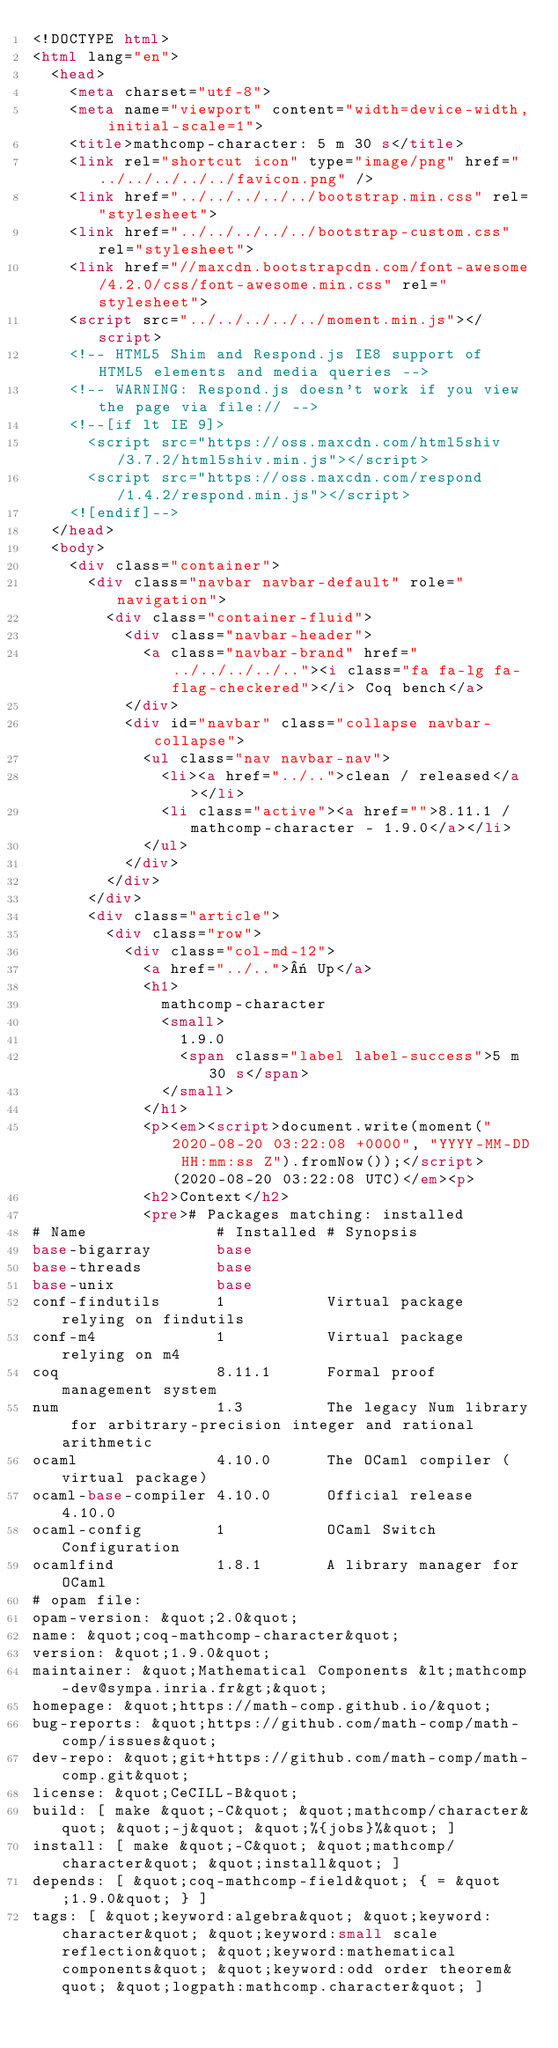<code> <loc_0><loc_0><loc_500><loc_500><_HTML_><!DOCTYPE html>
<html lang="en">
  <head>
    <meta charset="utf-8">
    <meta name="viewport" content="width=device-width, initial-scale=1">
    <title>mathcomp-character: 5 m 30 s</title>
    <link rel="shortcut icon" type="image/png" href="../../../../../favicon.png" />
    <link href="../../../../../bootstrap.min.css" rel="stylesheet">
    <link href="../../../../../bootstrap-custom.css" rel="stylesheet">
    <link href="//maxcdn.bootstrapcdn.com/font-awesome/4.2.0/css/font-awesome.min.css" rel="stylesheet">
    <script src="../../../../../moment.min.js"></script>
    <!-- HTML5 Shim and Respond.js IE8 support of HTML5 elements and media queries -->
    <!-- WARNING: Respond.js doesn't work if you view the page via file:// -->
    <!--[if lt IE 9]>
      <script src="https://oss.maxcdn.com/html5shiv/3.7.2/html5shiv.min.js"></script>
      <script src="https://oss.maxcdn.com/respond/1.4.2/respond.min.js"></script>
    <![endif]-->
  </head>
  <body>
    <div class="container">
      <div class="navbar navbar-default" role="navigation">
        <div class="container-fluid">
          <div class="navbar-header">
            <a class="navbar-brand" href="../../../../.."><i class="fa fa-lg fa-flag-checkered"></i> Coq bench</a>
          </div>
          <div id="navbar" class="collapse navbar-collapse">
            <ul class="nav navbar-nav">
              <li><a href="../..">clean / released</a></li>
              <li class="active"><a href="">8.11.1 / mathcomp-character - 1.9.0</a></li>
            </ul>
          </div>
        </div>
      </div>
      <div class="article">
        <div class="row">
          <div class="col-md-12">
            <a href="../..">« Up</a>
            <h1>
              mathcomp-character
              <small>
                1.9.0
                <span class="label label-success">5 m 30 s</span>
              </small>
            </h1>
            <p><em><script>document.write(moment("2020-08-20 03:22:08 +0000", "YYYY-MM-DD HH:mm:ss Z").fromNow());</script> (2020-08-20 03:22:08 UTC)</em><p>
            <h2>Context</h2>
            <pre># Packages matching: installed
# Name              # Installed # Synopsis
base-bigarray       base
base-threads        base
base-unix           base
conf-findutils      1           Virtual package relying on findutils
conf-m4             1           Virtual package relying on m4
coq                 8.11.1      Formal proof management system
num                 1.3         The legacy Num library for arbitrary-precision integer and rational arithmetic
ocaml               4.10.0      The OCaml compiler (virtual package)
ocaml-base-compiler 4.10.0      Official release 4.10.0
ocaml-config        1           OCaml Switch Configuration
ocamlfind           1.8.1       A library manager for OCaml
# opam file:
opam-version: &quot;2.0&quot;
name: &quot;coq-mathcomp-character&quot;
version: &quot;1.9.0&quot;
maintainer: &quot;Mathematical Components &lt;mathcomp-dev@sympa.inria.fr&gt;&quot;
homepage: &quot;https://math-comp.github.io/&quot;
bug-reports: &quot;https://github.com/math-comp/math-comp/issues&quot;
dev-repo: &quot;git+https://github.com/math-comp/math-comp.git&quot;
license: &quot;CeCILL-B&quot;
build: [ make &quot;-C&quot; &quot;mathcomp/character&quot; &quot;-j&quot; &quot;%{jobs}%&quot; ]
install: [ make &quot;-C&quot; &quot;mathcomp/character&quot; &quot;install&quot; ]
depends: [ &quot;coq-mathcomp-field&quot; { = &quot;1.9.0&quot; } ]
tags: [ &quot;keyword:algebra&quot; &quot;keyword:character&quot; &quot;keyword:small scale reflection&quot; &quot;keyword:mathematical components&quot; &quot;keyword:odd order theorem&quot; &quot;logpath:mathcomp.character&quot; ]</code> 